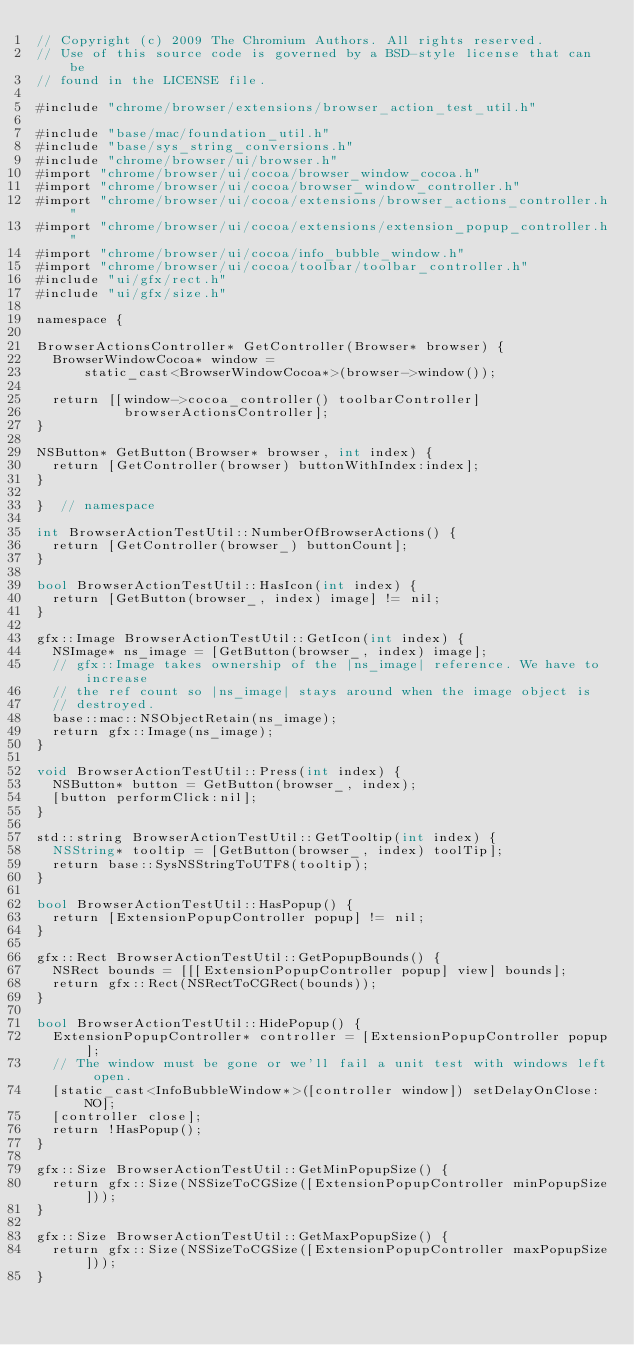<code> <loc_0><loc_0><loc_500><loc_500><_ObjectiveC_>// Copyright (c) 2009 The Chromium Authors. All rights reserved.
// Use of this source code is governed by a BSD-style license that can be
// found in the LICENSE file.

#include "chrome/browser/extensions/browser_action_test_util.h"

#include "base/mac/foundation_util.h"
#include "base/sys_string_conversions.h"
#include "chrome/browser/ui/browser.h"
#import "chrome/browser/ui/cocoa/browser_window_cocoa.h"
#import "chrome/browser/ui/cocoa/browser_window_controller.h"
#import "chrome/browser/ui/cocoa/extensions/browser_actions_controller.h"
#import "chrome/browser/ui/cocoa/extensions/extension_popup_controller.h"
#import "chrome/browser/ui/cocoa/info_bubble_window.h"
#import "chrome/browser/ui/cocoa/toolbar/toolbar_controller.h"
#include "ui/gfx/rect.h"
#include "ui/gfx/size.h"

namespace {

BrowserActionsController* GetController(Browser* browser) {
  BrowserWindowCocoa* window =
      static_cast<BrowserWindowCocoa*>(browser->window());

  return [[window->cocoa_controller() toolbarController]
           browserActionsController];
}

NSButton* GetButton(Browser* browser, int index) {
  return [GetController(browser) buttonWithIndex:index];
}

}  // namespace

int BrowserActionTestUtil::NumberOfBrowserActions() {
  return [GetController(browser_) buttonCount];
}

bool BrowserActionTestUtil::HasIcon(int index) {
  return [GetButton(browser_, index) image] != nil;
}

gfx::Image BrowserActionTestUtil::GetIcon(int index) {
  NSImage* ns_image = [GetButton(browser_, index) image];
  // gfx::Image takes ownership of the |ns_image| reference. We have to increase
  // the ref count so |ns_image| stays around when the image object is
  // destroyed.
  base::mac::NSObjectRetain(ns_image);
  return gfx::Image(ns_image);
}

void BrowserActionTestUtil::Press(int index) {
  NSButton* button = GetButton(browser_, index);
  [button performClick:nil];
}

std::string BrowserActionTestUtil::GetTooltip(int index) {
  NSString* tooltip = [GetButton(browser_, index) toolTip];
  return base::SysNSStringToUTF8(tooltip);
}

bool BrowserActionTestUtil::HasPopup() {
  return [ExtensionPopupController popup] != nil;
}

gfx::Rect BrowserActionTestUtil::GetPopupBounds() {
  NSRect bounds = [[[ExtensionPopupController popup] view] bounds];
  return gfx::Rect(NSRectToCGRect(bounds));
}

bool BrowserActionTestUtil::HidePopup() {
  ExtensionPopupController* controller = [ExtensionPopupController popup];
  // The window must be gone or we'll fail a unit test with windows left open.
  [static_cast<InfoBubbleWindow*>([controller window]) setDelayOnClose:NO];
  [controller close];
  return !HasPopup();
}

gfx::Size BrowserActionTestUtil::GetMinPopupSize() {
  return gfx::Size(NSSizeToCGSize([ExtensionPopupController minPopupSize]));
}

gfx::Size BrowserActionTestUtil::GetMaxPopupSize() {
  return gfx::Size(NSSizeToCGSize([ExtensionPopupController maxPopupSize]));
}
</code> 